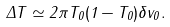<formula> <loc_0><loc_0><loc_500><loc_500>\Delta T \simeq 2 \pi T _ { 0 } ( 1 - T _ { 0 } ) \delta v _ { 0 } .</formula> 